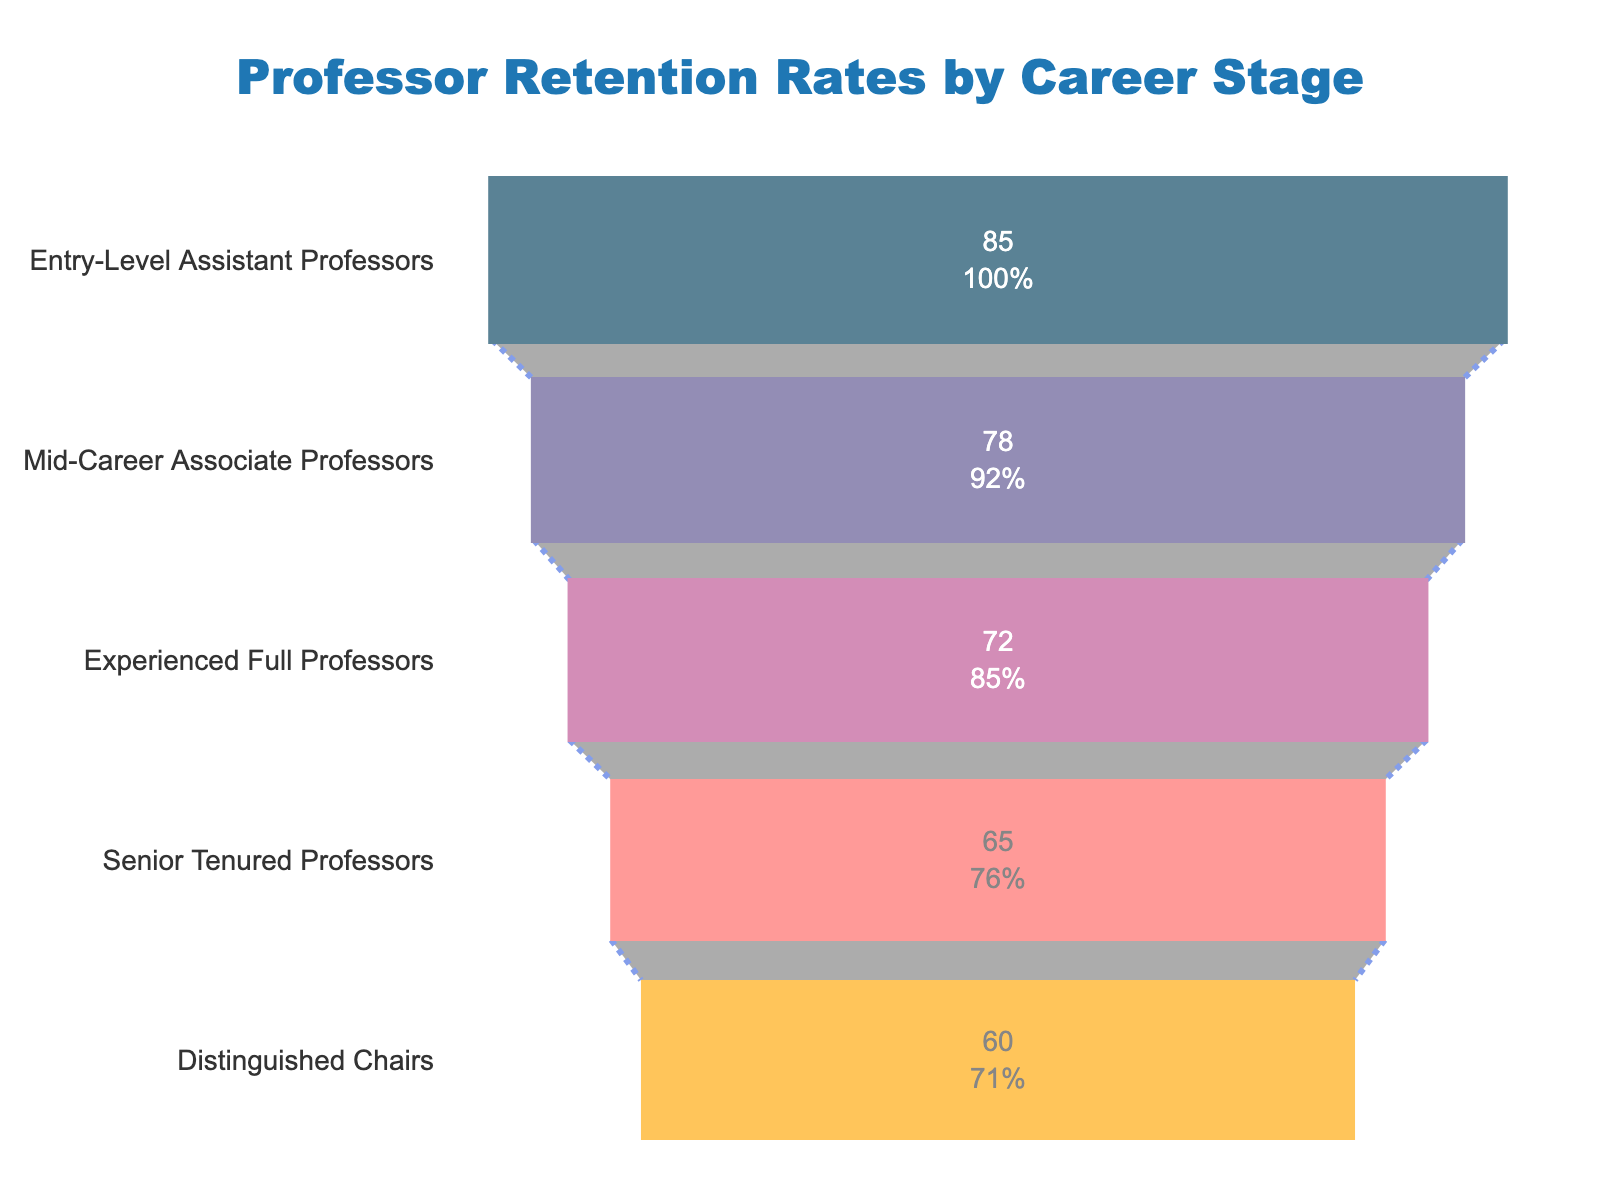What is the retention rate for Entry-Level Assistant Professors? The funnel chart shows that the retention rate for Entry-Level Assistant Professors is indicated at the top of the chart.
Answer: 85% What does the funnel chart represent? The title of the chart, positioned at the top, clearly indicates the chart's purpose.
Answer: Professor Retention Rates by Career Stage Which career stage has the lowest retention rate? By observing the bottom-most segment of the funnel chart, we can identify the career stage with the lowest retention rate.
Answer: Distinguished Chairs What is the difference in retention rates between Mid-Career Associate Professors and Senior Tenured Professors? The retention rates for the Mid-Career Associate Professors and Senior Tenured Professors are 78% and 65% respectively. Subtracting the latter from the former gives us the difference.
Answer: 13% What percent of initial retention is observed for Experienced Full Professors? Each stage of the funnel chart includes text inside the segment showing both absolute and percent of initial retention values; for Experienced Full Professors, this information is directly presented within its segment.
Answer: The exact value depends on the chart but usually follows the rate shown directly How does the retention rate of Distinguished Chairs compare to that of Mid-Career Associate Professors? By comparing the retention rate values for both segments, we can observe that Distinguished Chairs have a lower retention rate than Mid-Career Associate Professors. Specifically, 60% compared to 78%.
Answer: Distinguished Chairs have a lower retention rate Which stage experiences the steepest drop in retention rate compared to the previous stage? By examining the differences between each consecutive stage's retention rate, we can determine that the largest drop occurs between Experienced Full Professors and Senior Tenured Professors (72% to 65%).
Answer: Experienced Full Professors to Senior Tenured Professors How many career stages are represented in the funnel chart? Counting the distinct segments or career stage labels in the funnel chart yields the total number of stages.
Answer: 5 If we combine the percentages of Entry-Level Assistant Professors and Senior Tenured Professors, what is the result? Adding the retention rates of Entry-Level Assistant Professors (85%) and Senior Tenured Professors (65%) gives us the combined result.
Answer: 150% 